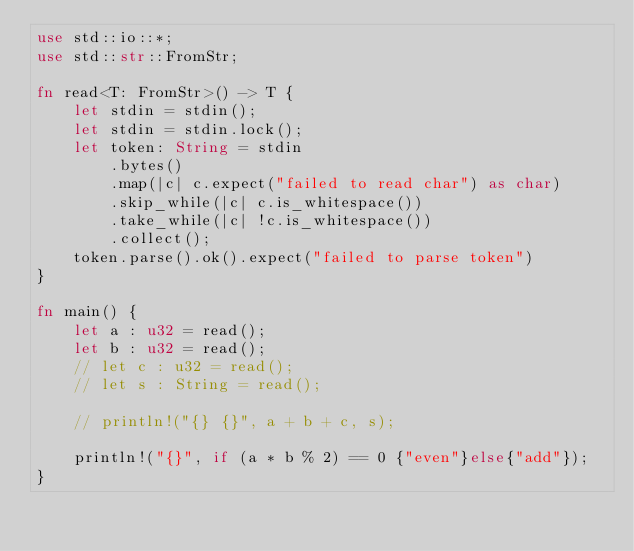<code> <loc_0><loc_0><loc_500><loc_500><_Rust_>use std::io::*;
use std::str::FromStr;

fn read<T: FromStr>() -> T {
    let stdin = stdin();
    let stdin = stdin.lock();
    let token: String = stdin
        .bytes()
        .map(|c| c.expect("failed to read char") as char) 
        .skip_while(|c| c.is_whitespace())
        .take_while(|c| !c.is_whitespace())
        .collect();
    token.parse().ok().expect("failed to parse token")
}

fn main() {
    let a : u32 = read();
    let b : u32 = read();
    // let c : u32 = read();
    // let s : String = read();

    // println!("{} {}", a + b + c, s);

    println!("{}", if (a * b % 2) == 0 {"even"}else{"add"});
}
</code> 